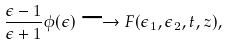<formula> <loc_0><loc_0><loc_500><loc_500>\frac { \epsilon - 1 } { \epsilon + 1 } \phi ( \epsilon ) \longrightarrow F ( \epsilon _ { 1 } , \epsilon _ { 2 } , t , z ) ,</formula> 